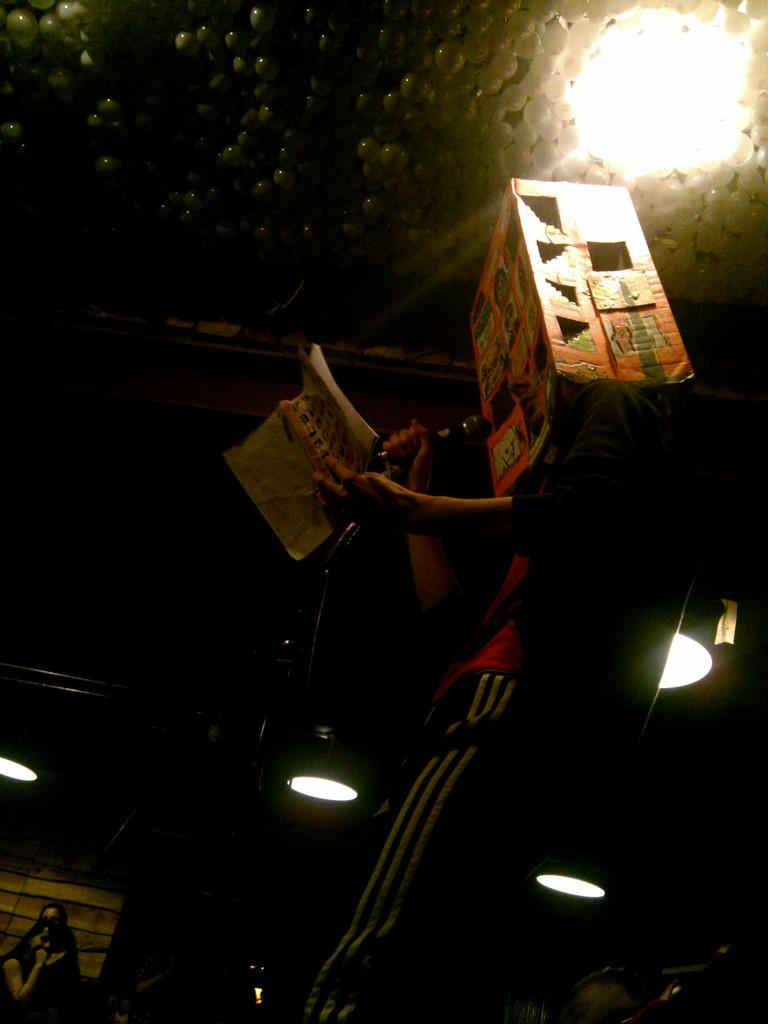What is the person in the image doing? The person is standing in the image and holding a mic and a book. What object is the person holding in addition to the mic? The person is holding a book. What is the person wearing in the image? The person is wearing a cardboard box. What can be seen in the background of the image? There are lights visible in the background. How would you describe the overall lighting in the image? The background of the image is dark. What type of yak can be seen grazing in the background of the image? There is no yak present in the image; the background features lights and a dark setting. How many divisions are visible in the book the person is holding? The image does not provide enough detail to determine the number of divisions in the book. 